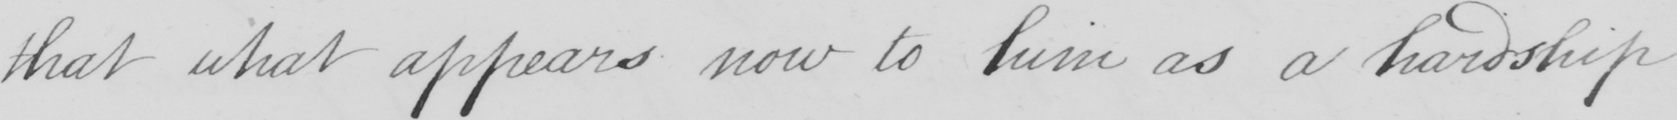Transcribe the text shown in this historical manuscript line. that what appears now to him as a hardship 